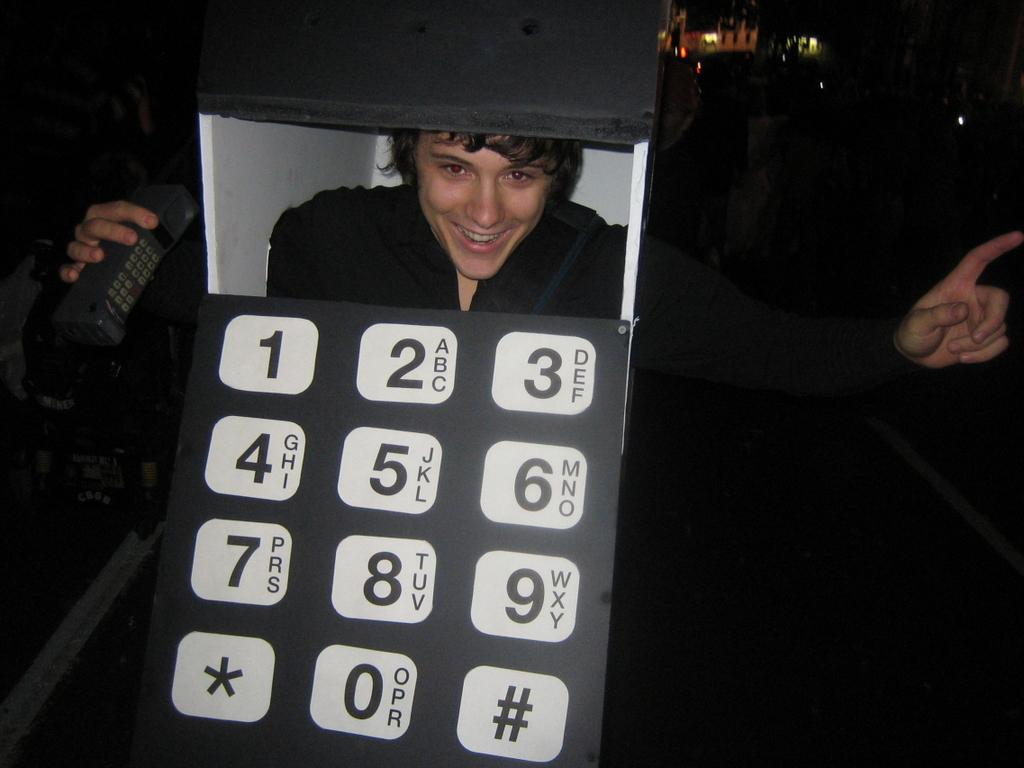What is the main subject of the image? There is a person in the image. What is the person wearing in the image? The person is wearing a cellphone costume. What is the person holding in the image? The person is holding a device in his hand. What additional feature can be seen on the person's costume? There are lights visible on the backside of the person. How many beds are visible in the image? There are no beds present in the image. What type of mark can be seen on the person's costume? There is no specific mark mentioned on the person's costume in the image. 